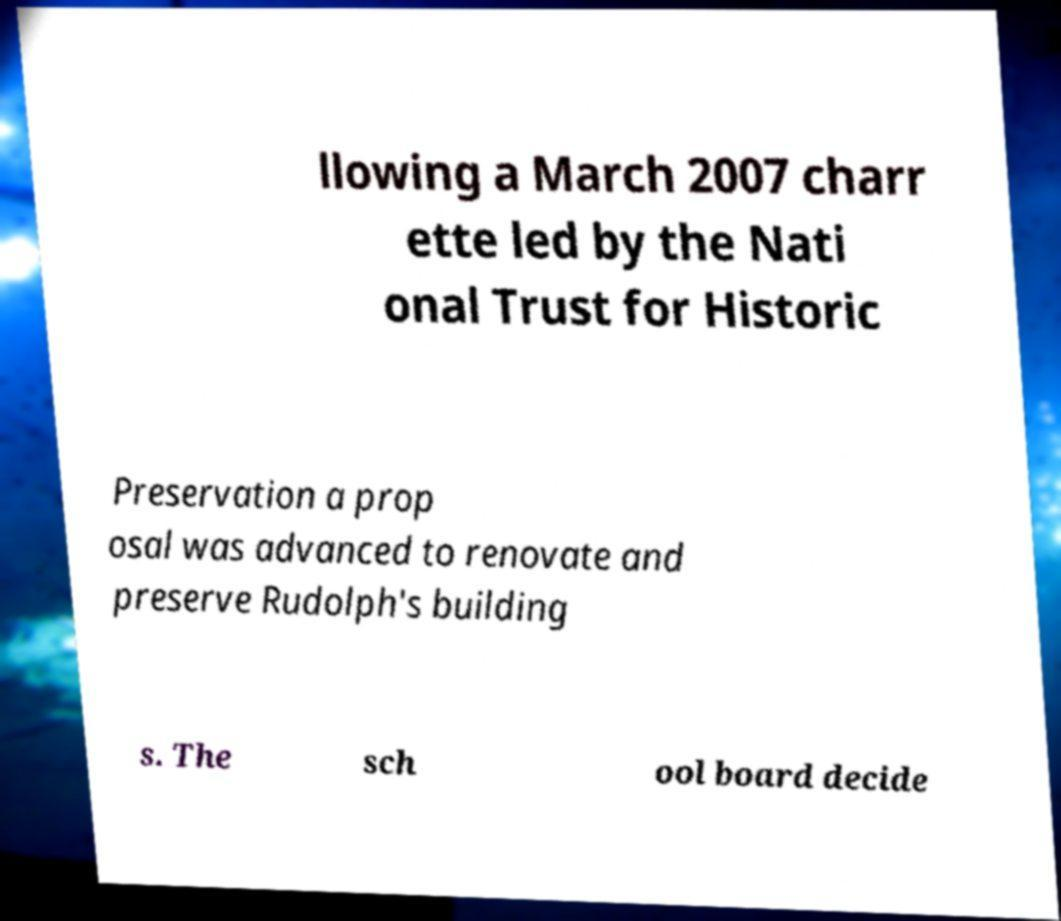I need the written content from this picture converted into text. Can you do that? llowing a March 2007 charr ette led by the Nati onal Trust for Historic Preservation a prop osal was advanced to renovate and preserve Rudolph's building s. The sch ool board decide 